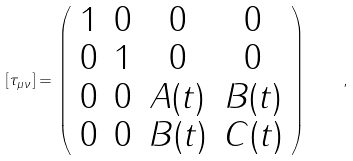<formula> <loc_0><loc_0><loc_500><loc_500>[ \tau _ { \mu \nu } ] = \left ( \begin{array} { c c c c } 1 & 0 & 0 & 0 \\ 0 & 1 & 0 & 0 \\ 0 & 0 & A ( t ) & B ( t ) \\ 0 & 0 & B ( t ) & C ( t ) \end{array} \right ) \quad ,</formula> 